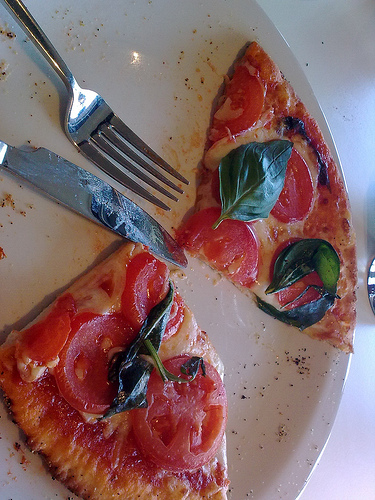<image>
Is the fork next to the plate? No. The fork is not positioned next to the plate. They are located in different areas of the scene. 